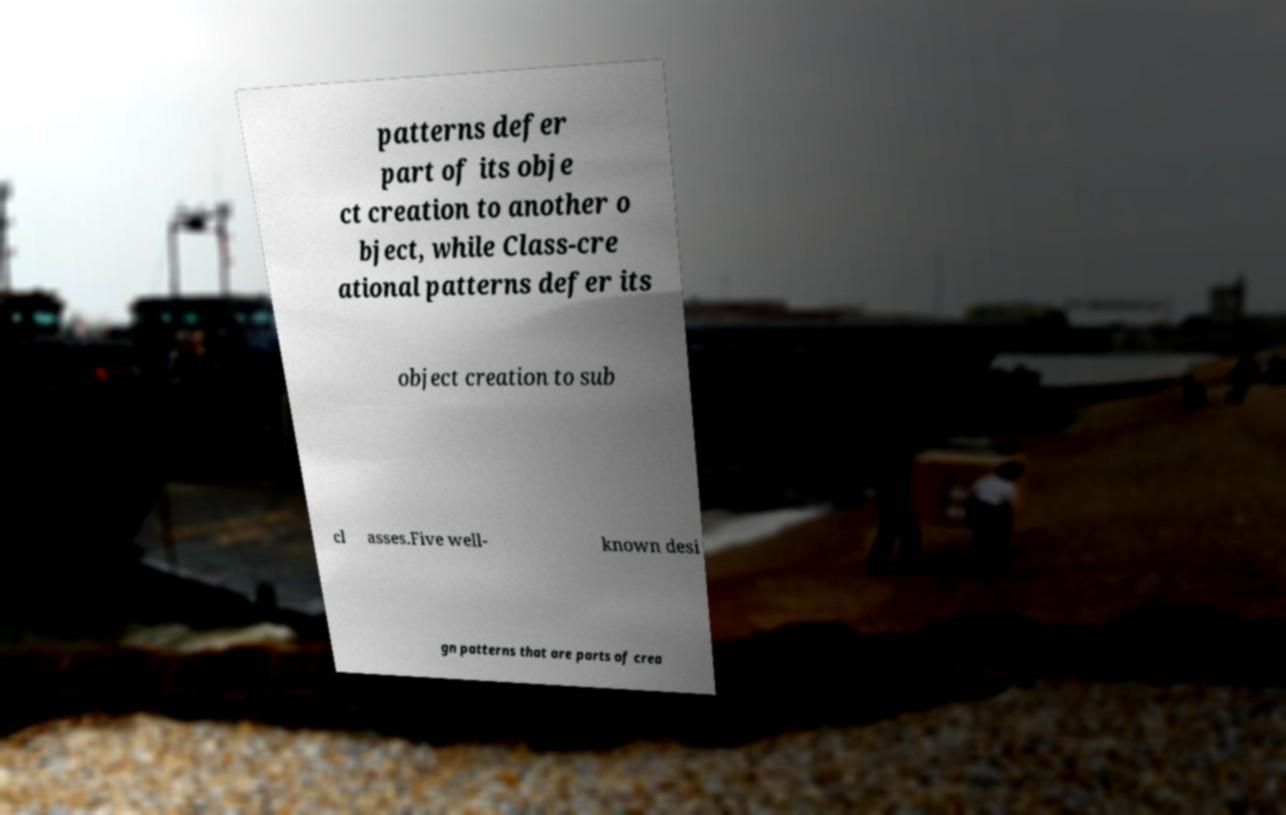What messages or text are displayed in this image? I need them in a readable, typed format. patterns defer part of its obje ct creation to another o bject, while Class-cre ational patterns defer its object creation to sub cl asses.Five well- known desi gn patterns that are parts of crea 